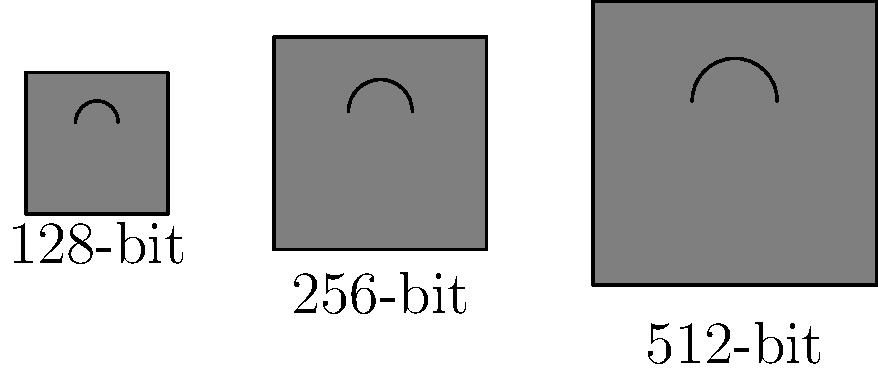In the context of cyber liability and data security, which encryption key length represented by the padlock icons would provide the highest level of protection against potential breaches? To determine which encryption key length provides the highest level of protection, we need to consider the relationship between key length and security:

1. The padlock icons represent different encryption key lengths: 128-bit, 256-bit, and 512-bit.

2. In encryption, a longer key length generally means:
   a) More possible key combinations
   b) Increased difficulty for brute-force attacks
   c) Higher computational requirements for encryption and decryption

3. The relationship between key length and security is exponential:
   - A 128-bit key has $2^{128}$ possible combinations
   - A 256-bit key has $2^{256}$ possible combinations
   - A 512-bit key has $2^{512}$ possible combinations

4. Each additional bit doubles the number of possible combinations, making it exponentially harder to crack.

5. In the image, the largest padlock corresponds to the 512-bit key, which visually represents its superior strength.

6. While 128-bit and 256-bit encryption are currently considered secure for most applications, the 512-bit key provides the highest level of protection among the options presented.

Therefore, the 512-bit encryption key length, represented by the largest padlock icon, would provide the highest level of protection against potential breaches in the context of cyber liability and data security.
Answer: 512-bit 